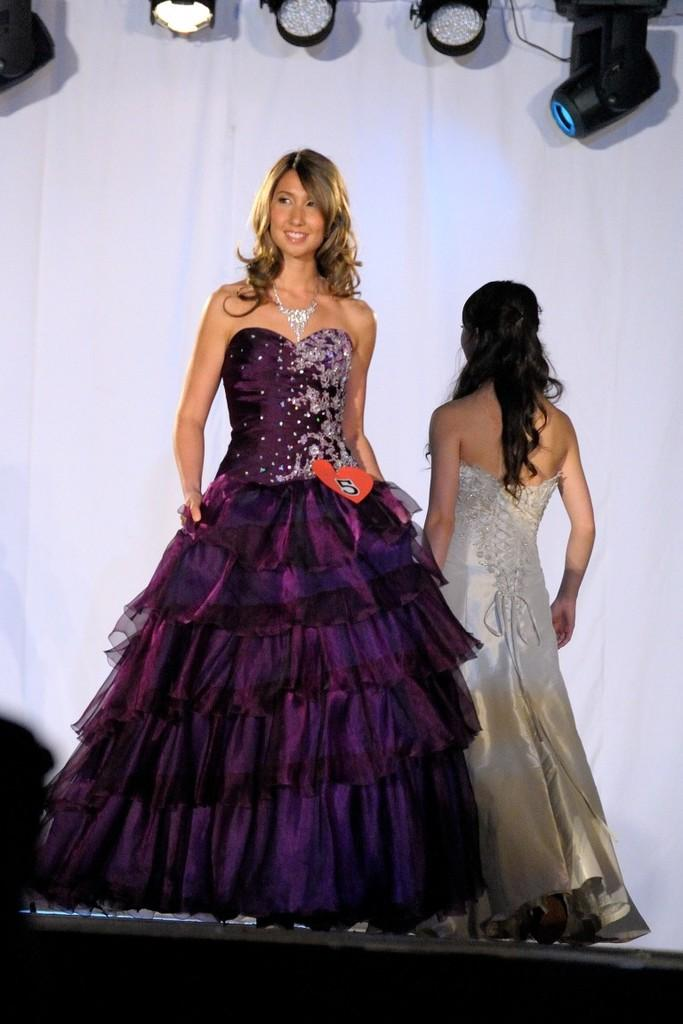How many people are in the image? There are two persons in the image. What can be seen in the image besides the people? Lights are visible in the image. What is the background of the image? The background of the image resembles a wall. What type of lettuce is being used as a prop in the image? There is no lettuce present in the image. 